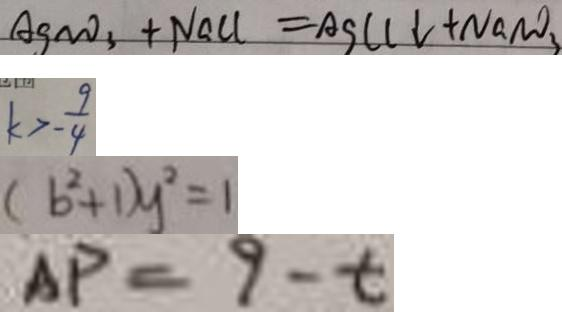<formula> <loc_0><loc_0><loc_500><loc_500>A g N O _ { 3 } + N a C l \downarrow = A g C l \downarrow + N a N O _ { 3 } 
 k > - \frac { 9 } { 4 } 
 ( b ^ { 2 } + 1 ) y ^ { 2 } = 1 
 A P = 9 - t</formula> 